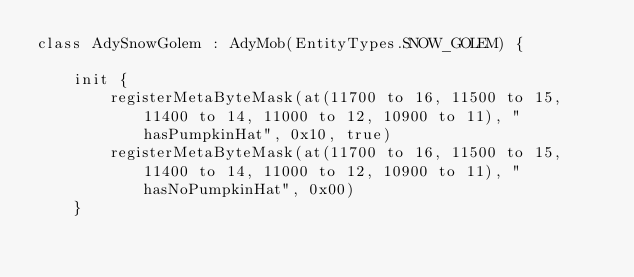<code> <loc_0><loc_0><loc_500><loc_500><_Kotlin_>class AdySnowGolem : AdyMob(EntityTypes.SNOW_GOLEM) {

    init {
        registerMetaByteMask(at(11700 to 16, 11500 to 15, 11400 to 14, 11000 to 12, 10900 to 11), "hasPumpkinHat", 0x10, true)
        registerMetaByteMask(at(11700 to 16, 11500 to 15, 11400 to 14, 11000 to 12, 10900 to 11), "hasNoPumpkinHat", 0x00)
    }
</code> 